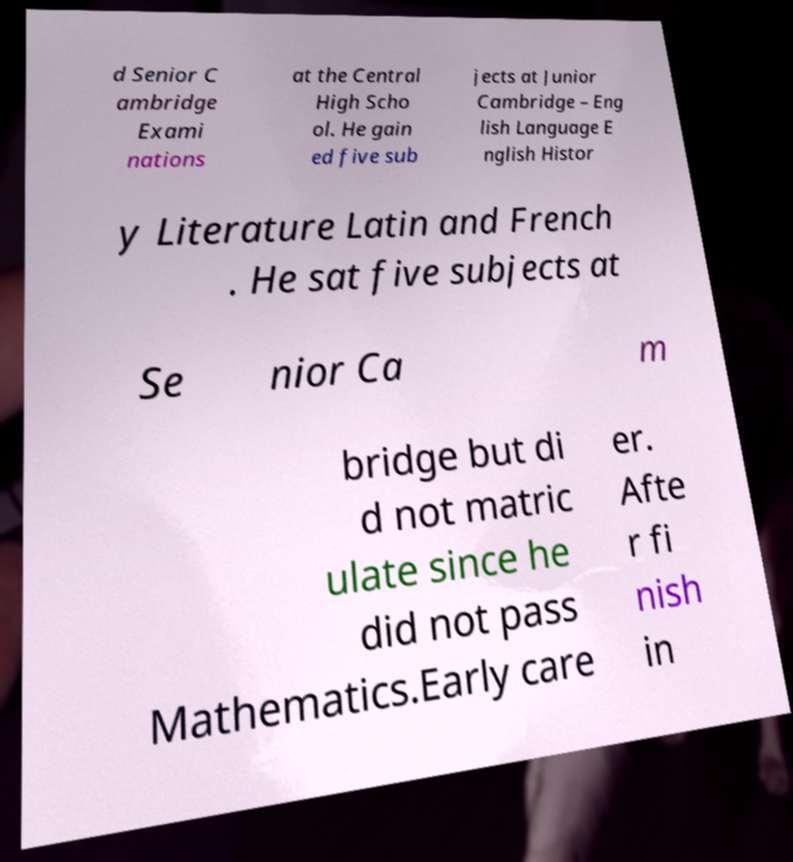Can you read and provide the text displayed in the image?This photo seems to have some interesting text. Can you extract and type it out for me? d Senior C ambridge Exami nations at the Central High Scho ol. He gain ed five sub jects at Junior Cambridge – Eng lish Language E nglish Histor y Literature Latin and French . He sat five subjects at Se nior Ca m bridge but di d not matric ulate since he did not pass Mathematics.Early care er. Afte r fi nish in 